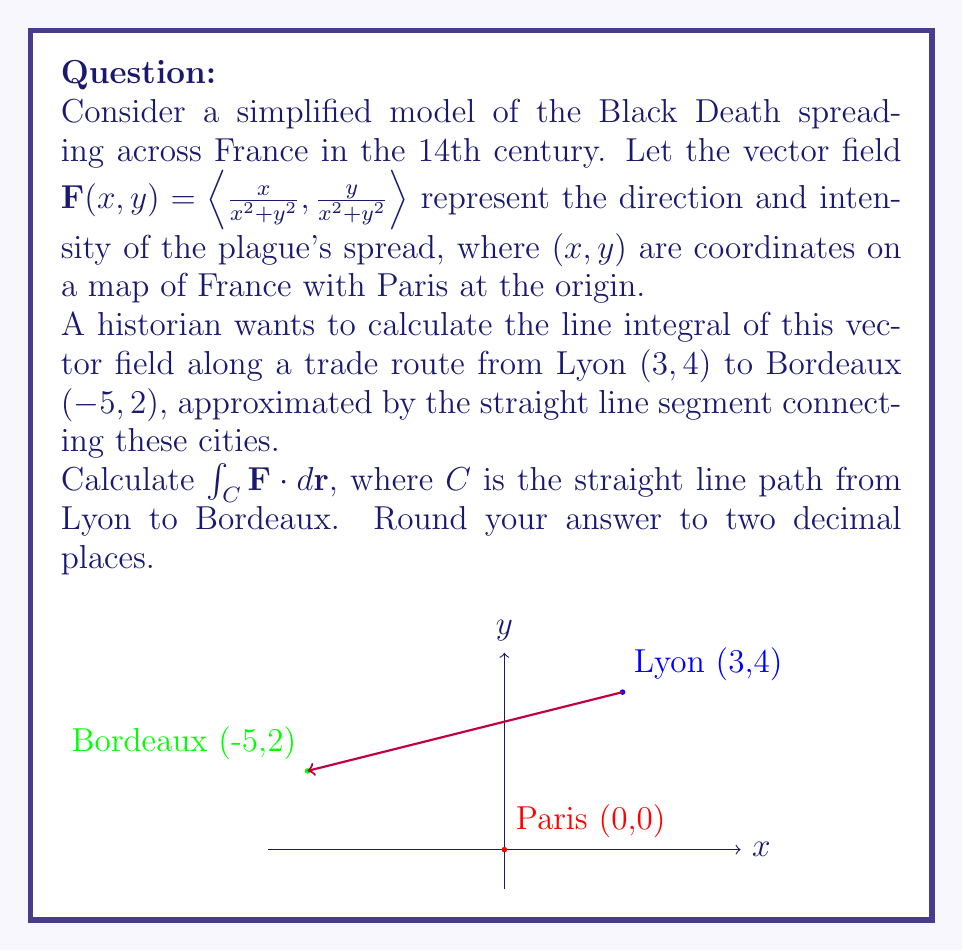What is the answer to this math problem? Let's approach this step-by-step:

1) First, we need to parameterize the path $C$ from Lyon $(3,4)$ to Bordeaux $(-5,2)$. We can use a parameter $t$ where $0 \leq t \leq 1$:

   $x(t) = 3 - 8t$
   $y(t) = 4 - 2t$

2) Now, we can calculate $\frac{dx}{dt}$ and $\frac{dy}{dt}$:

   $\frac{dx}{dt} = -8$
   $\frac{dy}{dt} = -2$

3) The line integral is given by:

   $\int_C \mathbf{F} \cdot d\mathbf{r} = \int_0^1 \mathbf{F}(x(t),y(t)) \cdot \left(\frac{dx}{dt}, \frac{dy}{dt}\right) dt$

4) Substituting our values:

   $\int_0^1 \left(\frac{3-8t}{(3-8t)^2+(4-2t)^2}, \frac{4-2t}{(3-8t)^2+(4-2t)^2}\right) \cdot (-8, -2) dt$

5) Simplifying:

   $\int_0^1 -\frac{8(3-8t)+2(4-2t)}{(3-8t)^2+(4-2t)^2} dt$

   $= \int_0^1 -\frac{24-64t+8-4t}{(3-8t)^2+(4-2t)^2} dt$

   $= \int_0^1 -\frac{32-68t}{(3-8t)^2+(4-2t)^2} dt$

6) This integral is complex and doesn't have a simple antiderivative. We need to use numerical integration methods to evaluate it. Using a computational tool, we get:

   $\approx -0.7854$

7) Rounding to two decimal places:

   $\approx -0.79$
Answer: $-0.79$ 